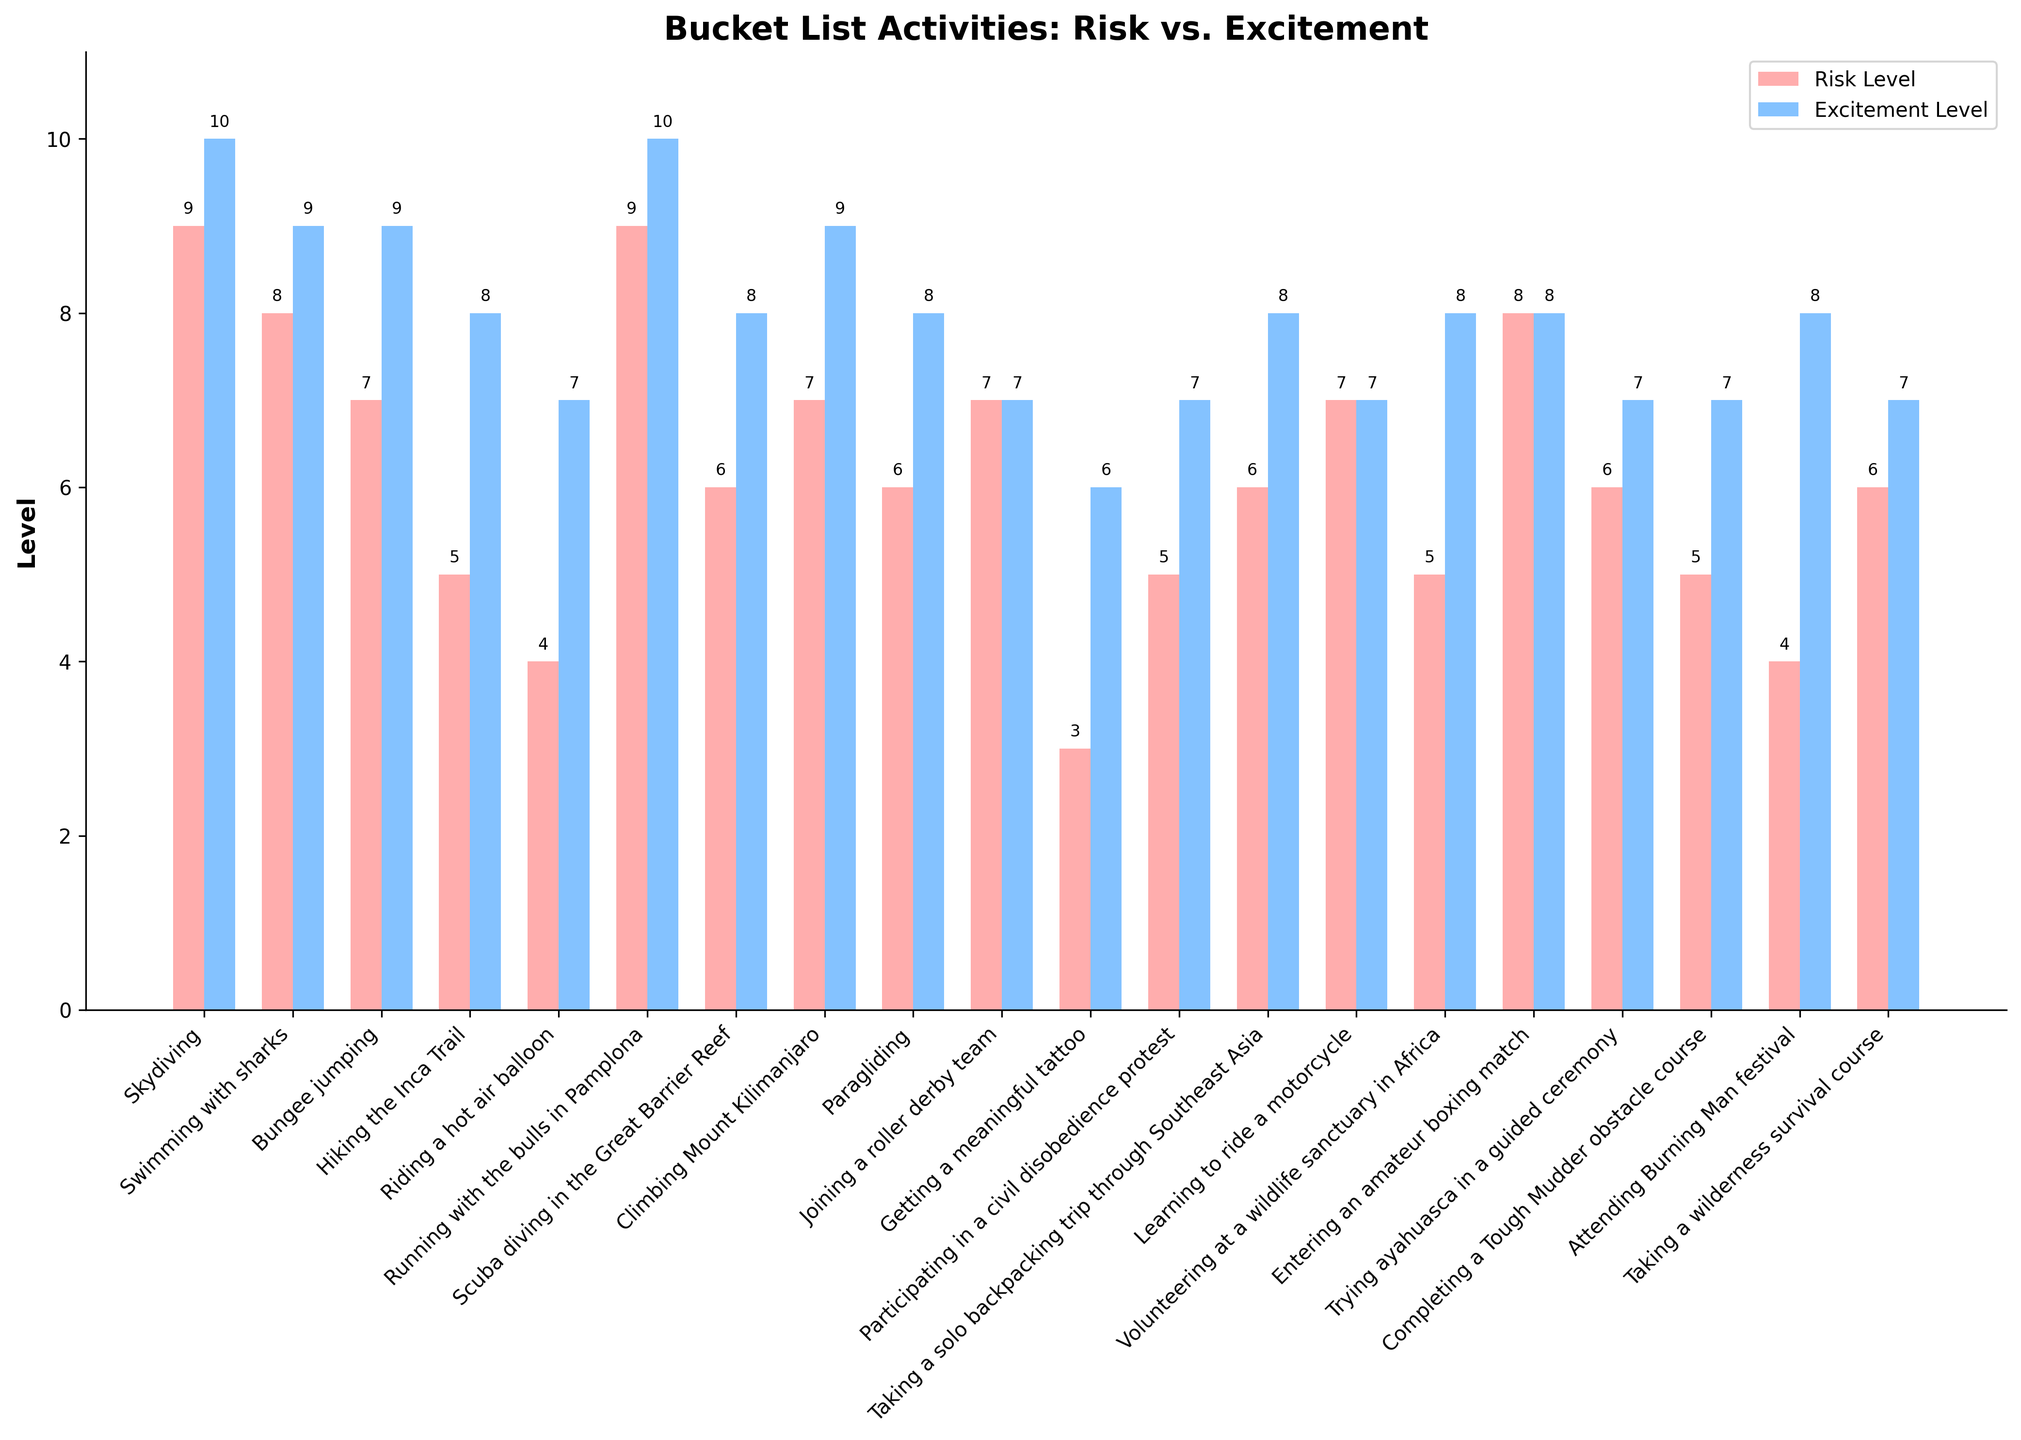Which activity has the highest perceived risk level? The activity with the highest risk level will have the tallest red bar in the chart. By visually inspecting the red bars, we can see that Skydiving and Running with the bulls in Pamplona both have the tallest bars with a risk level of 9.
Answer: Skydiving and Running with the bulls in Pamplona What is the difference in perceived risk level between Climbing Mount Kilimanjaro and Riding a hot air balloon? The difference in perceived risk level is calculated by subtracting the risk level of Riding a hot air balloon (4) from the risk level of Climbing Mount Kilimanjaro (7). So, it is 7 - 4 = 3.
Answer: 3 Find the average excitement level of activities with a risk level greater than 7. First, list the activities with risk levels greater than 7: Skydiving (10), Swimming with sharks (9), Running with the bulls in Pamplona (10), Entering an amateur boxing match (8). Next, sum their excitement levels: 10 + 9 + 10 + 8 = 37. Finally, divide by the number of activities (4): 37 / 4 = 9.25.
Answer: 9.25 Which activity has the same perceived risk and excitement level? Look for bars where both the red and blue bars are of equal height. Joining a roller derby team and Learning to ride a motorcycle both have risk and excitement levels of 7.
Answer: Joining a roller derby team and Learning to ride a motorcycle Compare the excitement level of Hiking the Inca Trail and Completing a Tough Mudder obstacle course. Which one is higher? Check the blue bars corresponding to these activities. Hiking the Inca Trail has an excitement level of 8, while Completing a Tough Mudder obstacle course has an excitement level of 7.
Answer: Hiking the Inca Trail What is the combined excitement level of Volunteering at a wildlife sanctuary in Africa and Taking a wilderness survival course? Sum the excitement levels of Volunteering at a wildlife sanctuary in Africa (8) and Taking a wilderness survival course (7). 8 + 7 = 15.
Answer: 15 Which activity has the lowest perceived risk level? The activity with the lowest risk level corresponds to the shortest red bar in the chart. Getting a meaningful tattoo has a risk level of 3, which is the lowest.
Answer: Getting a meaningful tattoo How many activities have both risk and excitement levels at or above 8? Identify activities where both the red and blue bars are at least 8 units tall. These are Skydiving, Swimming with sharks, Running with the bulls in Pamplona, and Entering an amateur boxing match. There are 4 such activities.
Answer: 4 Which activity's excitement level is equal to the perceived risk level of Riding a hot air balloon? Look for an activity with an excitement level of 4 (the risk level of Riding a hot air balloon). None of the activities have an excitement level of 4.
Answer: None Is the perceived risk level of Paragliding higher, lower, or equal to that of Taking a solo backpacking trip through Southeast Asia? Compare the red bars for Paragliding and Taking a solo backpacking trip through Southeast Asia. Both activities have a risk level of 6, so they are equal.
Answer: Equal 